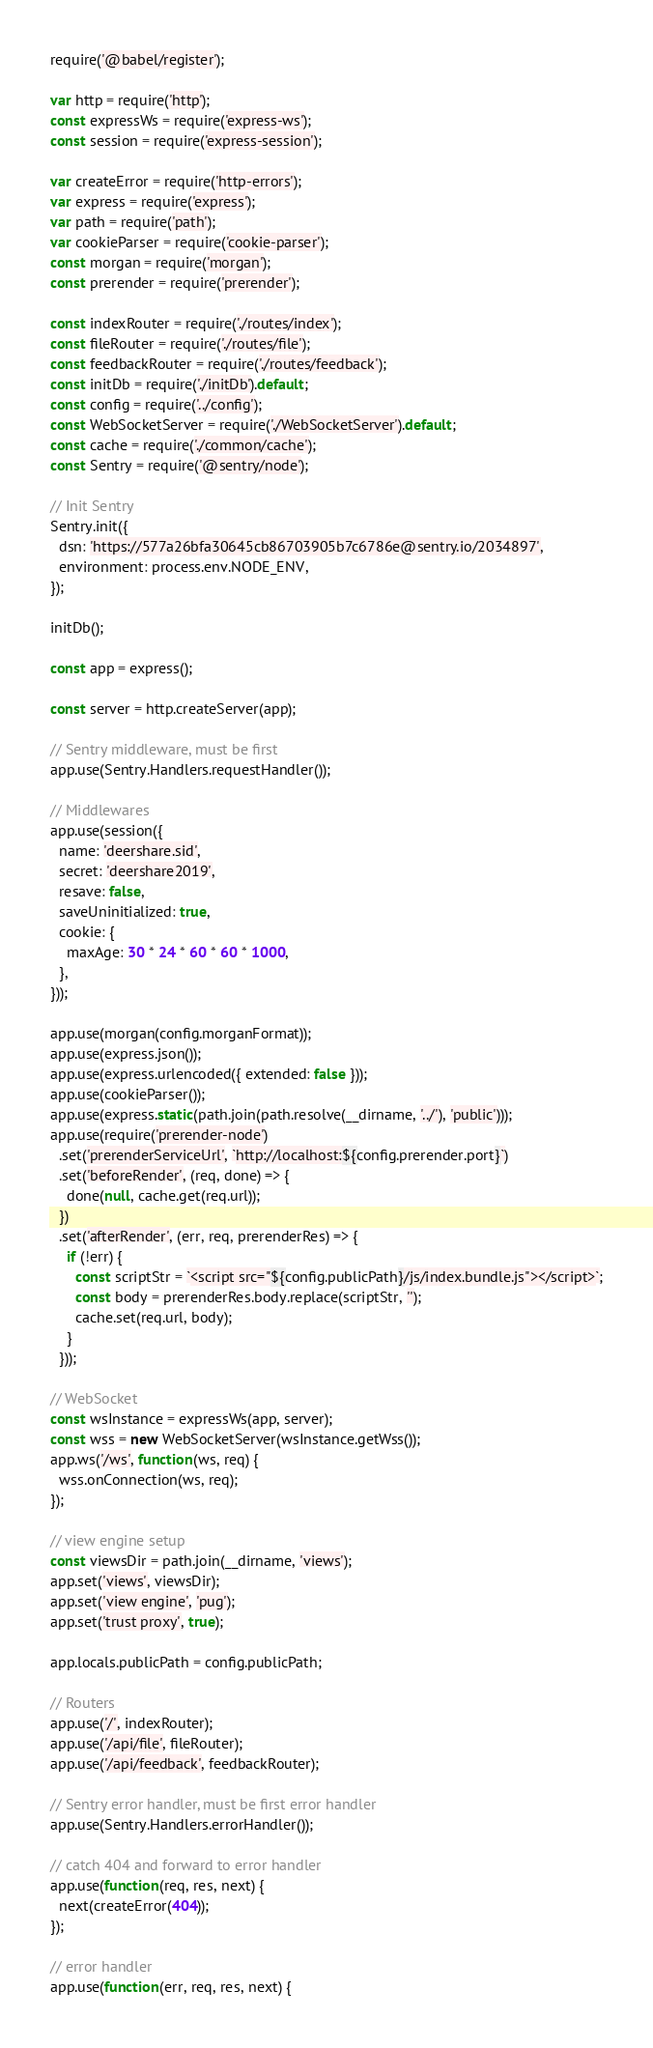<code> <loc_0><loc_0><loc_500><loc_500><_JavaScript_>require('@babel/register');

var http = require('http');
const expressWs = require('express-ws');
const session = require('express-session');

var createError = require('http-errors');
var express = require('express');
var path = require('path');
var cookieParser = require('cookie-parser');
const morgan = require('morgan');
const prerender = require('prerender');

const indexRouter = require('./routes/index');
const fileRouter = require('./routes/file');
const feedbackRouter = require('./routes/feedback');
const initDb = require('./initDb').default;
const config = require('../config');
const WebSocketServer = require('./WebSocketServer').default;
const cache = require('./common/cache');
const Sentry = require('@sentry/node');

// Init Sentry
Sentry.init({
  dsn: 'https://577a26bfa30645cb86703905b7c6786e@sentry.io/2034897',
  environment: process.env.NODE_ENV,
});

initDb();

const app = express();

const server = http.createServer(app);

// Sentry middleware, must be first
app.use(Sentry.Handlers.requestHandler());

// Middlewares
app.use(session({
  name: 'deershare.sid',
  secret: 'deershare2019',
  resave: false,
  saveUninitialized: true,
  cookie: {
    maxAge: 30 * 24 * 60 * 60 * 1000,
  },
}));

app.use(morgan(config.morganFormat));
app.use(express.json());
app.use(express.urlencoded({ extended: false }));
app.use(cookieParser());
app.use(express.static(path.join(path.resolve(__dirname, '../'), 'public')));
app.use(require('prerender-node')
  .set('prerenderServiceUrl', `http://localhost:${config.prerender.port}`)
  .set('beforeRender', (req, done) => {
    done(null, cache.get(req.url));
  })
  .set('afterRender', (err, req, prerenderRes) => {
    if (!err) {
      const scriptStr = `<script src="${config.publicPath}/js/index.bundle.js"></script>`;
      const body = prerenderRes.body.replace(scriptStr, '');
      cache.set(req.url, body);
    }
  }));

// WebSocket
const wsInstance = expressWs(app, server);
const wss = new WebSocketServer(wsInstance.getWss());
app.ws('/ws', function(ws, req) {
  wss.onConnection(ws, req);
});

// view engine setup
const viewsDir = path.join(__dirname, 'views');
app.set('views', viewsDir);
app.set('view engine', 'pug');
app.set('trust proxy', true);

app.locals.publicPath = config.publicPath;

// Routers
app.use('/', indexRouter);
app.use('/api/file', fileRouter);
app.use('/api/feedback', feedbackRouter);

// Sentry error handler, must be first error handler
app.use(Sentry.Handlers.errorHandler());

// catch 404 and forward to error handler
app.use(function(req, res, next) {
  next(createError(404));
});

// error handler
app.use(function(err, req, res, next) {</code> 